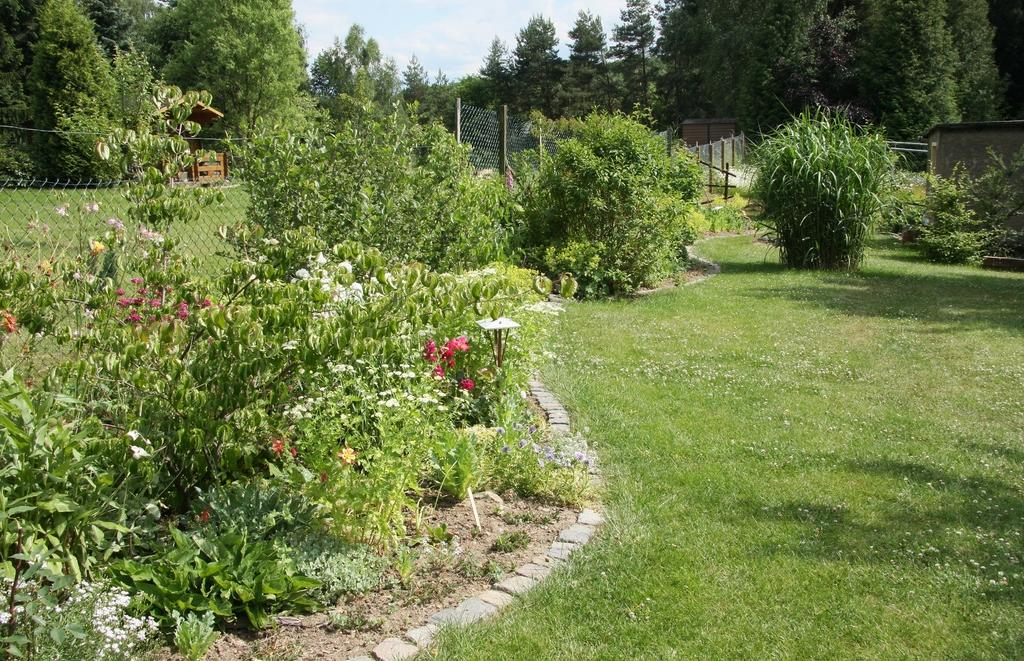What is located in the foreground of the image? There are plants and grassland in the foreground of the image. What type of vegetation can be seen in the image? There are trees in the image. What might indicate a separation or division in the image? It appears to be a boundary or border in the image. What can be seen in the background of the image? The sky is visible in the background of the image. What shape is the idea taking in the image? There is no idea present in the image, as it is a visual representation of a scene with plants, grassland, trees, a boundary, and the sky. How many fingers can be seen interacting with the plants in the image? There are no fingers or hands visible in the image; it is a landscape scene with no human presence. 